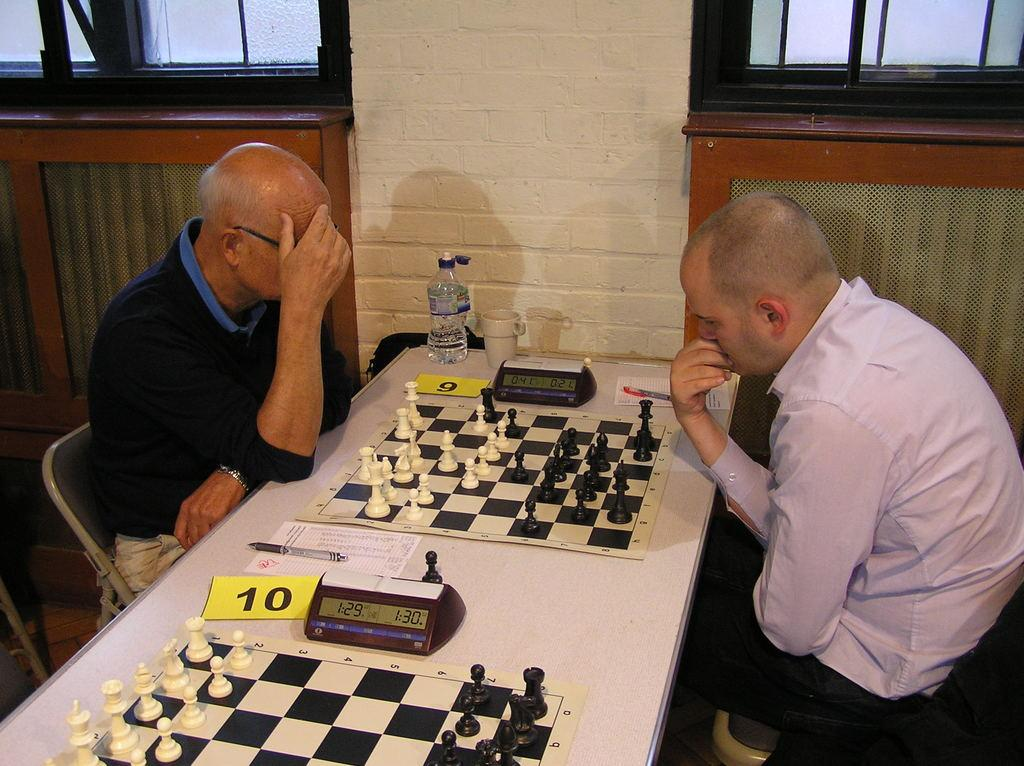How many people are sitting in the image? There are two persons sitting on chairs in the image. What is on the table in the image? There is a chess board, a clock, a paper, a pen, a bottle, and a cup on the table in the image. What can be seen in the background of the image? There is a wall and a window in the background of the image. What type of doll is sitting on the table in the image? There is no doll present on the table in the image. How many buildings can be seen through the window in the image? There is only one window visible in the background, and it is not possible to determine the number of buildings from the image. 